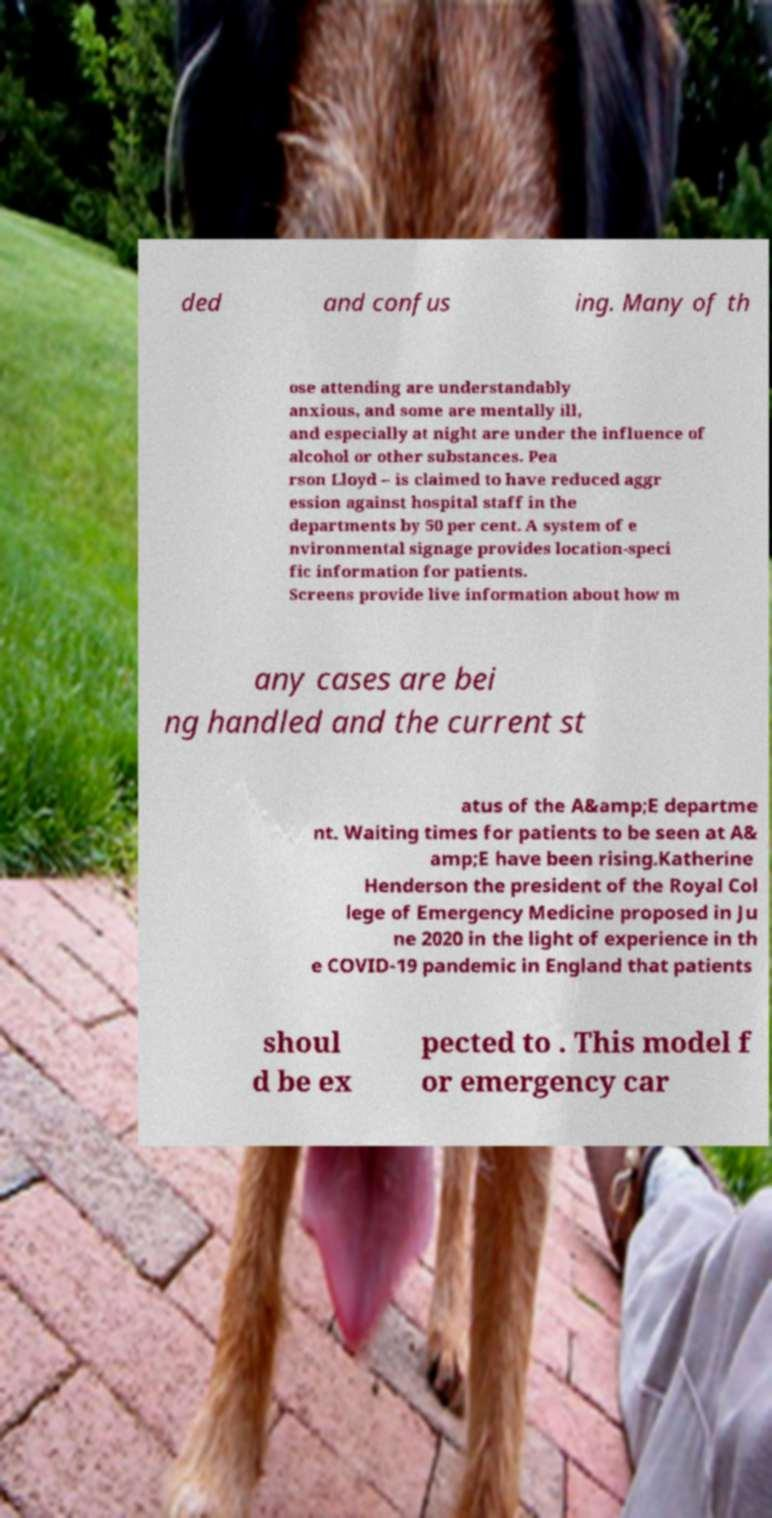I need the written content from this picture converted into text. Can you do that? ded and confus ing. Many of th ose attending are understandably anxious, and some are mentally ill, and especially at night are under the influence of alcohol or other substances. Pea rson Lloyd – is claimed to have reduced aggr ession against hospital staff in the departments by 50 per cent. A system of e nvironmental signage provides location-speci fic information for patients. Screens provide live information about how m any cases are bei ng handled and the current st atus of the A&amp;E departme nt. Waiting times for patients to be seen at A& amp;E have been rising.Katherine Henderson the president of the Royal Col lege of Emergency Medicine proposed in Ju ne 2020 in the light of experience in th e COVID-19 pandemic in England that patients shoul d be ex pected to . This model f or emergency car 